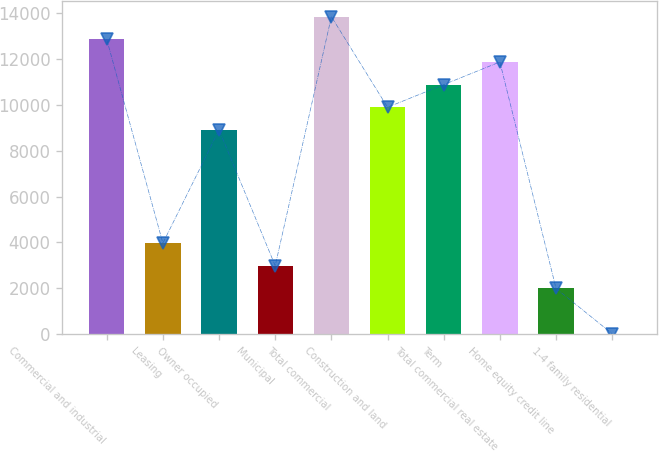<chart> <loc_0><loc_0><loc_500><loc_500><bar_chart><fcel>Commercial and industrial<fcel>Leasing<fcel>Owner occupied<fcel>Municipal<fcel>Total commercial<fcel>Construction and land<fcel>Term<fcel>Total commercial real estate<fcel>Home equity credit line<fcel>1-4 family residential<nl><fcel>12860.6<fcel>3966.8<fcel>8907.8<fcel>2978.6<fcel>13848.8<fcel>9896<fcel>10884.2<fcel>11872.4<fcel>1990.4<fcel>14<nl></chart> 